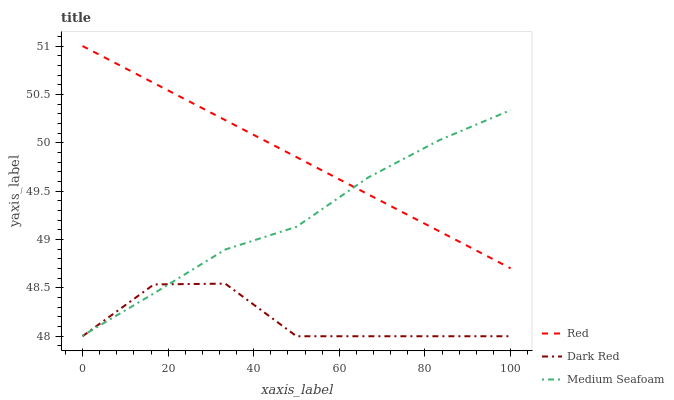Does Dark Red have the minimum area under the curve?
Answer yes or no. Yes. Does Red have the maximum area under the curve?
Answer yes or no. Yes. Does Medium Seafoam have the minimum area under the curve?
Answer yes or no. No. Does Medium Seafoam have the maximum area under the curve?
Answer yes or no. No. Is Red the smoothest?
Answer yes or no. Yes. Is Dark Red the roughest?
Answer yes or no. Yes. Is Medium Seafoam the smoothest?
Answer yes or no. No. Is Medium Seafoam the roughest?
Answer yes or no. No. Does Dark Red have the lowest value?
Answer yes or no. Yes. Does Medium Seafoam have the lowest value?
Answer yes or no. No. Does Red have the highest value?
Answer yes or no. Yes. Does Medium Seafoam have the highest value?
Answer yes or no. No. Is Dark Red less than Red?
Answer yes or no. Yes. Is Red greater than Dark Red?
Answer yes or no. Yes. Does Red intersect Medium Seafoam?
Answer yes or no. Yes. Is Red less than Medium Seafoam?
Answer yes or no. No. Is Red greater than Medium Seafoam?
Answer yes or no. No. Does Dark Red intersect Red?
Answer yes or no. No. 